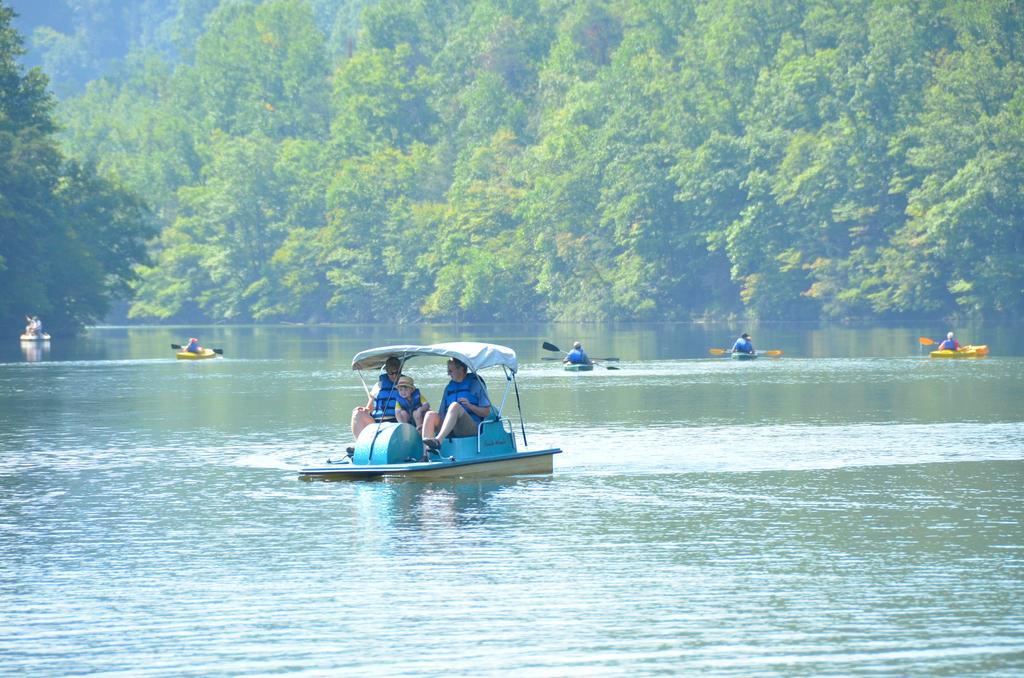What is the primary element visible in the image? There is water in the image. What are the persons in the image doing? The persons are sitting in a boat. Where is the boat located in the image? The boat is sailing on a river. What can be seen in the background of the image? There are trees in the background of the image. What type of poison is being used by the yak in the image? There is no yak or poison present in the image. How many pages are visible in the image? There are no pages present in the image. 